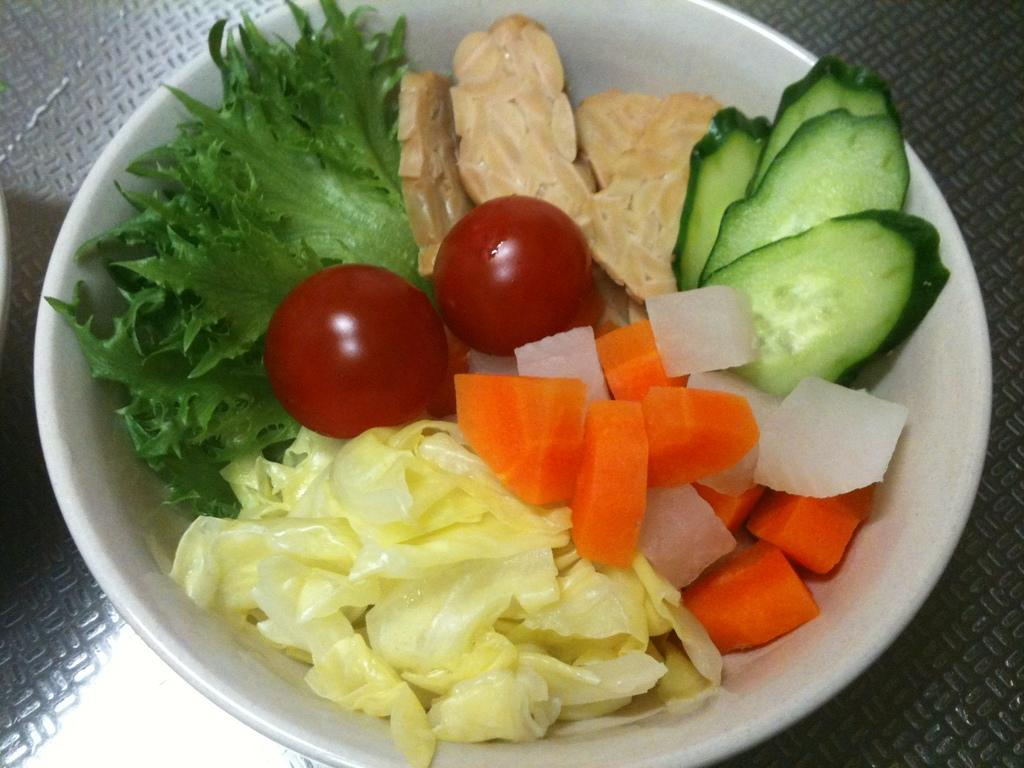What is the main subject in the center of the image? There is an object in the center of the image. What is placed on top of the object? There is a bowl on the object. What can be found inside the bowl? There are food items in the bowl. What type of card is hanging from the hook in the image? There is no card or hook present in the image. 